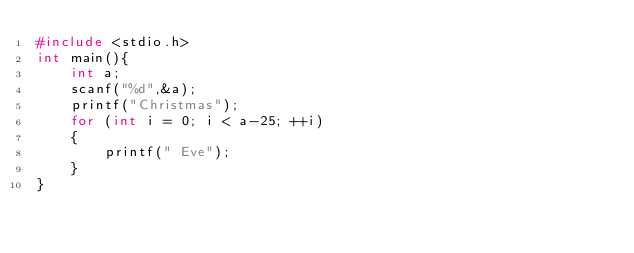<code> <loc_0><loc_0><loc_500><loc_500><_C_>#include <stdio.h>
int main(){
	int a;
	scanf("%d",&a);
	printf("Christmas");
	for (int i = 0; i < a-25; ++i)
	{
		printf(" Eve");
	}
}</code> 